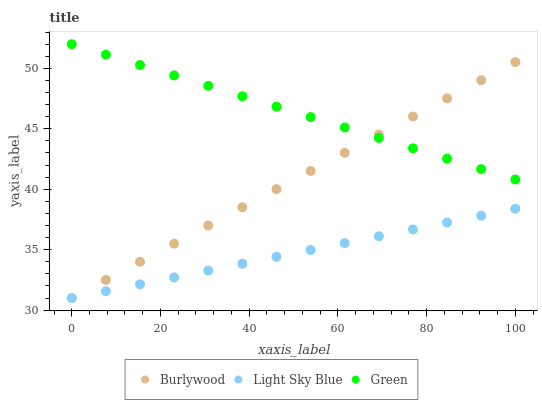Does Light Sky Blue have the minimum area under the curve?
Answer yes or no. Yes. Does Green have the maximum area under the curve?
Answer yes or no. Yes. Does Green have the minimum area under the curve?
Answer yes or no. No. Does Light Sky Blue have the maximum area under the curve?
Answer yes or no. No. Is Burlywood the smoothest?
Answer yes or no. Yes. Is Light Sky Blue the roughest?
Answer yes or no. Yes. Is Green the smoothest?
Answer yes or no. No. Is Green the roughest?
Answer yes or no. No. Does Burlywood have the lowest value?
Answer yes or no. Yes. Does Green have the lowest value?
Answer yes or no. No. Does Green have the highest value?
Answer yes or no. Yes. Does Light Sky Blue have the highest value?
Answer yes or no. No. Is Light Sky Blue less than Green?
Answer yes or no. Yes. Is Green greater than Light Sky Blue?
Answer yes or no. Yes. Does Light Sky Blue intersect Burlywood?
Answer yes or no. Yes. Is Light Sky Blue less than Burlywood?
Answer yes or no. No. Is Light Sky Blue greater than Burlywood?
Answer yes or no. No. Does Light Sky Blue intersect Green?
Answer yes or no. No. 